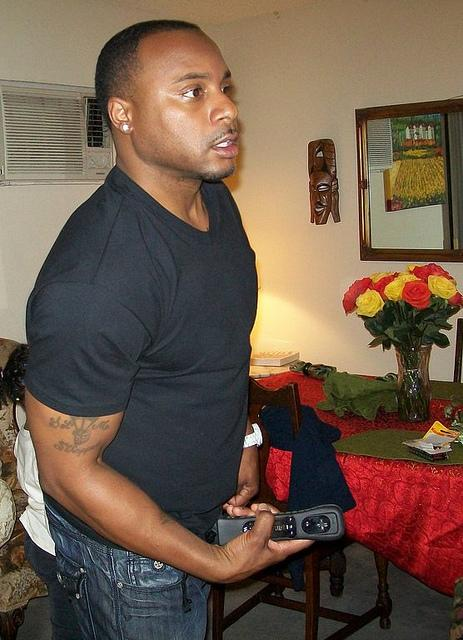The remote is meant to communicate with what? Please explain your reasoning. television. The remote has buttons to change channels. 